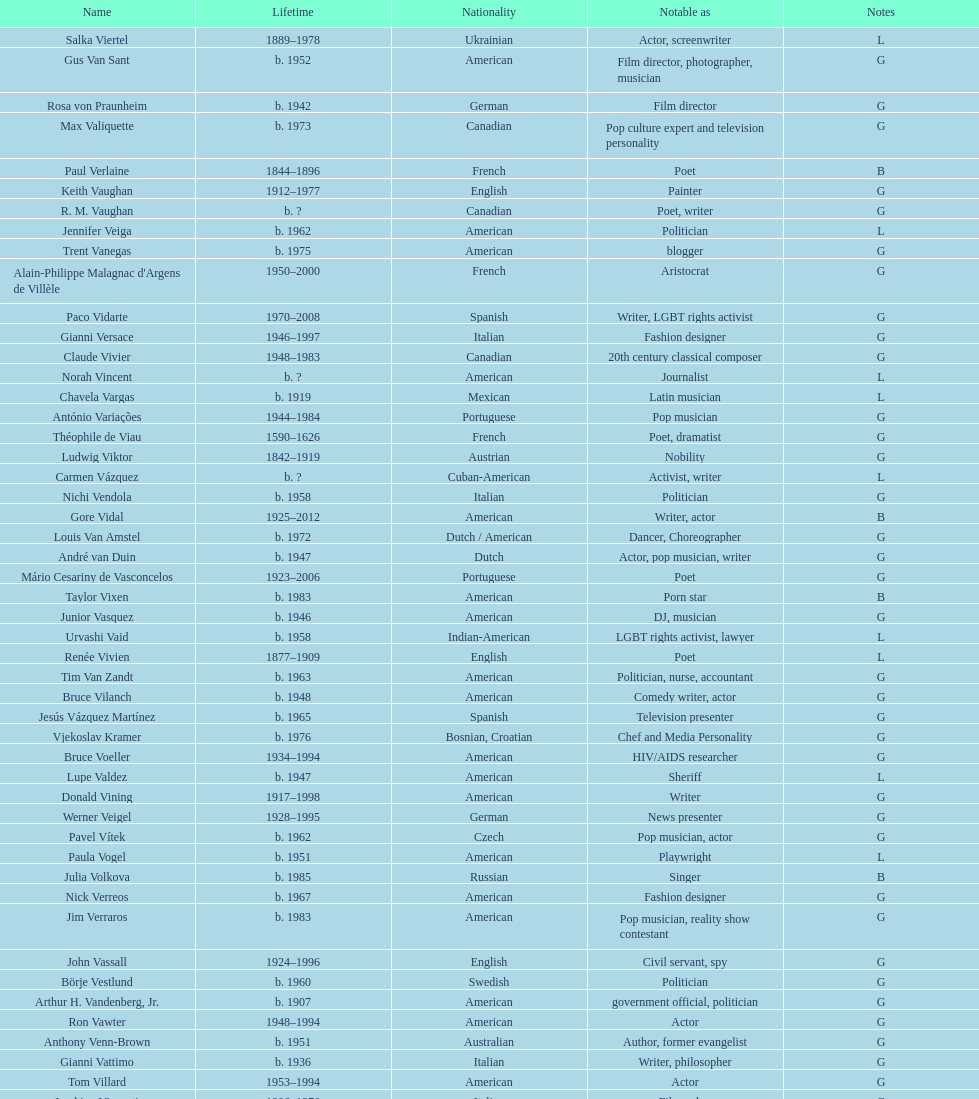Who lived longer, van vechten or variacoes? Van Vechten. 